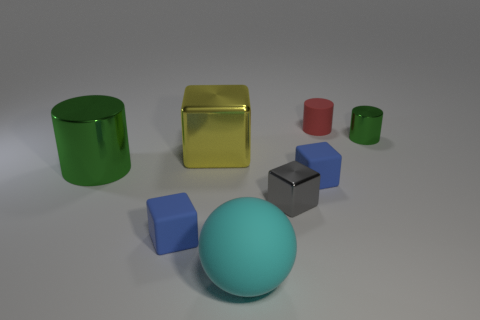Do the cyan thing and the red cylinder have the same size?
Make the answer very short. No. What number of metallic objects are both right of the red cylinder and in front of the large yellow cube?
Keep it short and to the point. 0. Are the large green cylinder and the tiny gray object made of the same material?
Your answer should be compact. Yes. There is a gray thing that is the same size as the red object; what shape is it?
Make the answer very short. Cube. Are there more small matte blocks than big green cylinders?
Your response must be concise. Yes. What material is the cube that is both behind the gray object and to the left of the sphere?
Ensure brevity in your answer.  Metal. How many other objects are the same material as the red object?
Provide a succinct answer. 3. What number of objects have the same color as the small metallic cylinder?
Give a very brief answer. 1. What size is the object that is behind the metal thing to the right of the small blue matte thing on the right side of the gray metal block?
Ensure brevity in your answer.  Small. What number of metal things are either cylinders or spheres?
Ensure brevity in your answer.  2. 